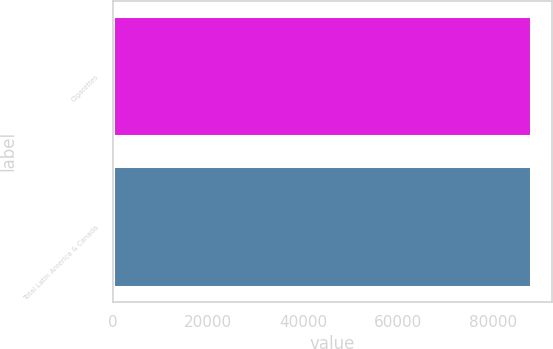<chart> <loc_0><loc_0><loc_500><loc_500><bar_chart><fcel>Cigarettes<fcel>Total Latin America & Canada<nl><fcel>87938<fcel>87938.1<nl></chart> 